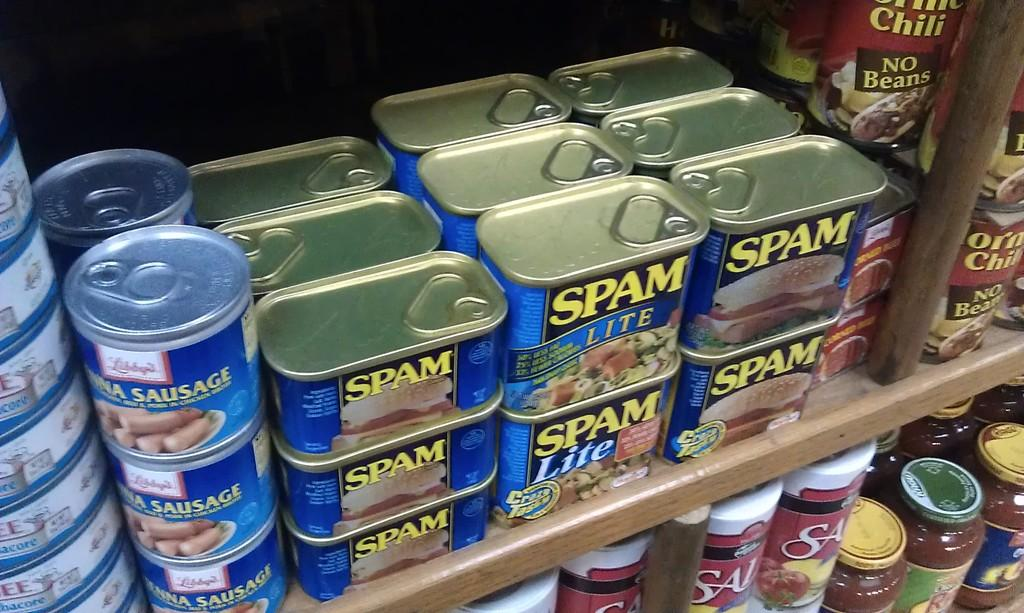Provide a one-sentence caption for the provided image. Many cans of spam are stacked on a shelf in a store. 